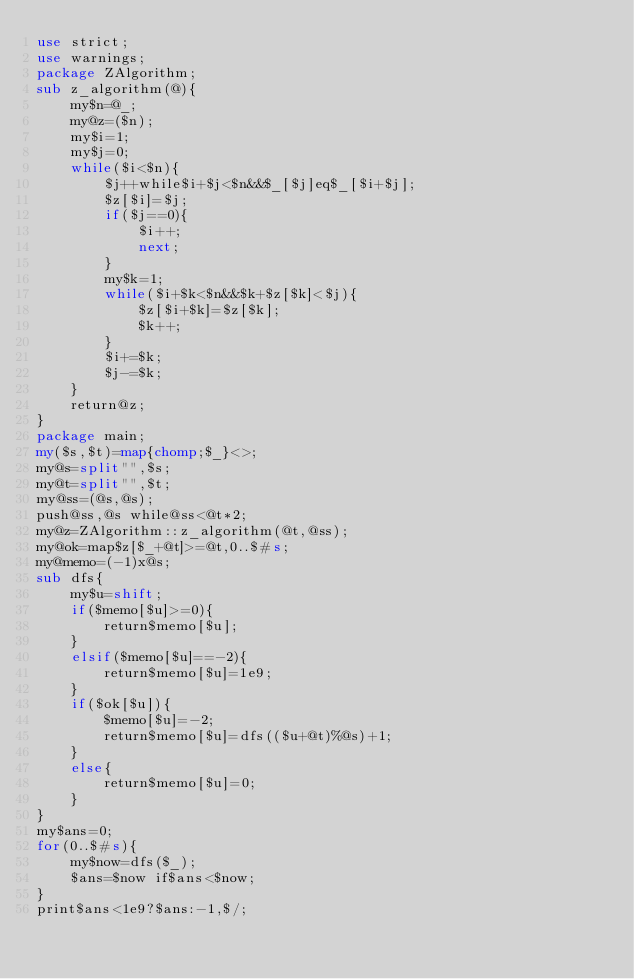Convert code to text. <code><loc_0><loc_0><loc_500><loc_500><_Perl_>use strict;
use warnings;
package ZAlgorithm;
sub z_algorithm(@){
	my$n=@_;
	my@z=($n);
	my$i=1;
	my$j=0;
	while($i<$n){
		$j++while$i+$j<$n&&$_[$j]eq$_[$i+$j];
		$z[$i]=$j;
		if($j==0){
			$i++;
			next;
		}
		my$k=1;
		while($i+$k<$n&&$k+$z[$k]<$j){
			$z[$i+$k]=$z[$k];
			$k++;
		}
		$i+=$k;
		$j-=$k;
	}
	return@z;
}
package main;
my($s,$t)=map{chomp;$_}<>;
my@s=split"",$s;
my@t=split"",$t;
my@ss=(@s,@s);
push@ss,@s while@ss<@t*2;
my@z=ZAlgorithm::z_algorithm(@t,@ss);
my@ok=map$z[$_+@t]>=@t,0..$#s;
my@memo=(-1)x@s;
sub dfs{
	my$u=shift;
	if($memo[$u]>=0){
		return$memo[$u];
	}
	elsif($memo[$u]==-2){
		return$memo[$u]=1e9;
	}
	if($ok[$u]){
		$memo[$u]=-2;
		return$memo[$u]=dfs(($u+@t)%@s)+1;
	}
	else{
		return$memo[$u]=0;
	}
}
my$ans=0;
for(0..$#s){
	my$now=dfs($_);
	$ans=$now if$ans<$now;
}
print$ans<1e9?$ans:-1,$/;
</code> 